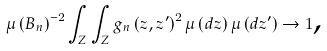<formula> <loc_0><loc_0><loc_500><loc_500>\mu \left ( B _ { n } \right ) ^ { - 2 } \int _ { Z } \int _ { Z } g _ { n } \left ( z , z ^ { \prime } \right ) ^ { 2 } \mu \left ( d z \right ) \mu \left ( d z ^ { \prime } \right ) \rightarrow 1 \text {,}</formula> 